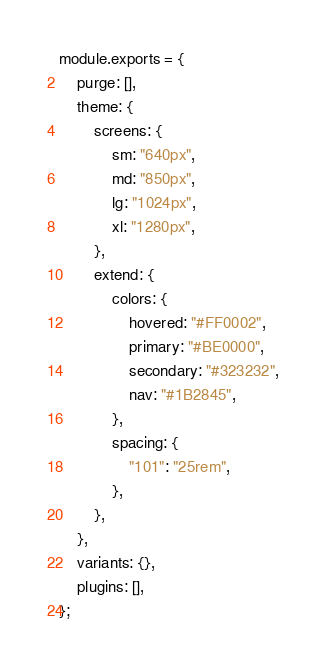<code> <loc_0><loc_0><loc_500><loc_500><_JavaScript_>module.exports = {
    purge: [],
    theme: {
        screens: {
            sm: "640px",
            md: "850px",
            lg: "1024px",
            xl: "1280px",
        },
        extend: {
            colors: {
                hovered: "#FF0002",
                primary: "#BE0000",
                secondary: "#323232",
                nav: "#1B2845",
            },
            spacing: {
                "101": "25rem",
            },
        },
    },
    variants: {},
    plugins: [],
};
</code> 